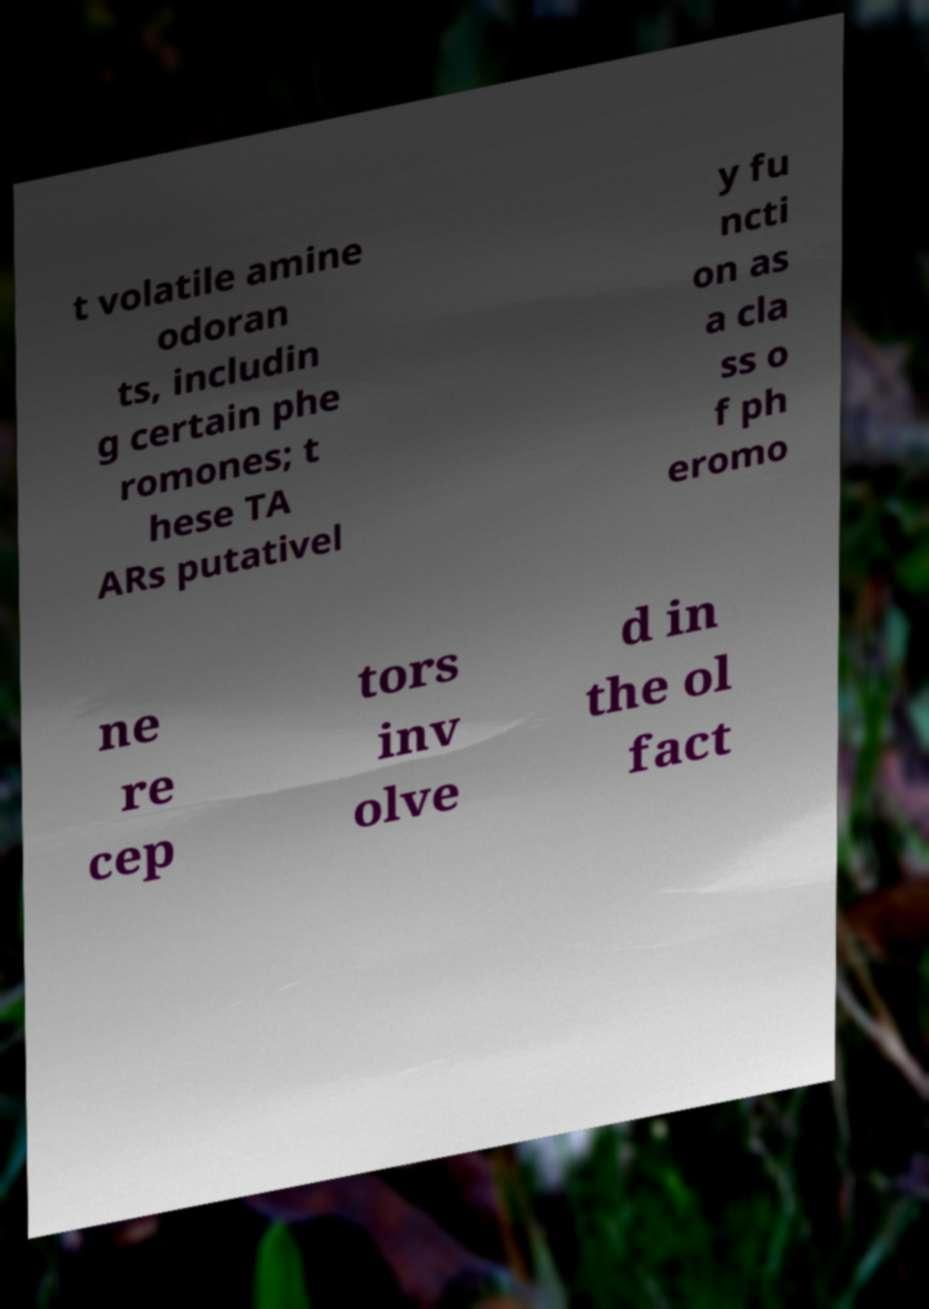Please read and relay the text visible in this image. What does it say? t volatile amine odoran ts, includin g certain phe romones; t hese TA ARs putativel y fu ncti on as a cla ss o f ph eromo ne re cep tors inv olve d in the ol fact 